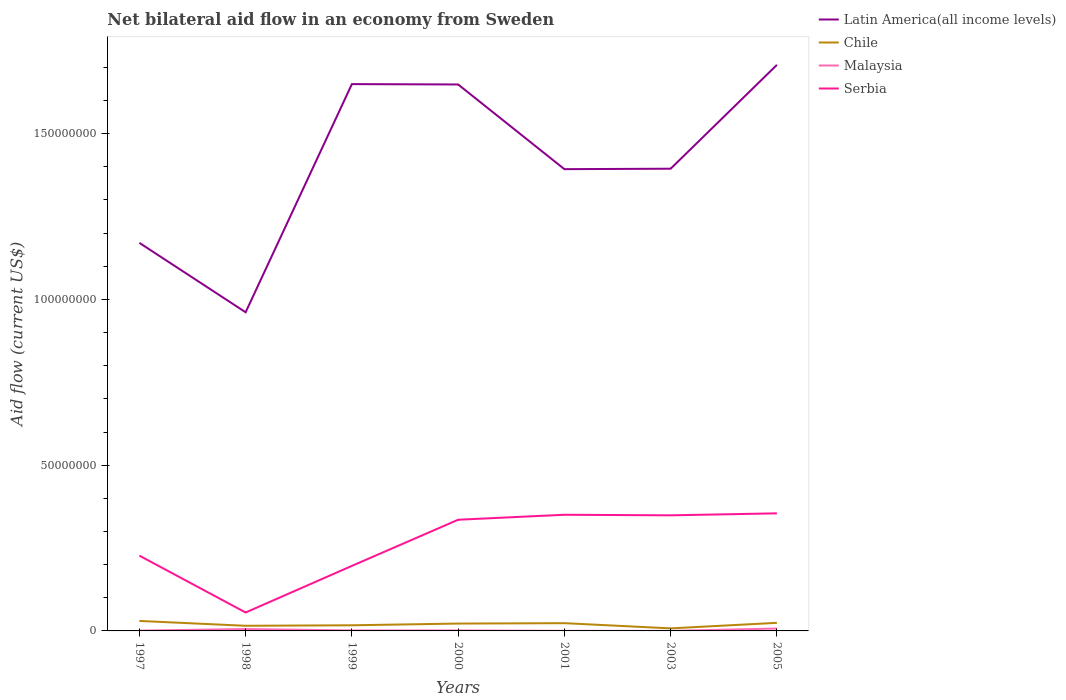Does the line corresponding to Latin America(all income levels) intersect with the line corresponding to Malaysia?
Offer a terse response. No. Across all years, what is the maximum net bilateral aid flow in Latin America(all income levels)?
Your answer should be very brief. 9.61e+07. In which year was the net bilateral aid flow in Chile maximum?
Make the answer very short. 2003. What is the total net bilateral aid flow in Chile in the graph?
Your answer should be very brief. -6.40e+05. What is the difference between the highest and the second highest net bilateral aid flow in Malaysia?
Provide a succinct answer. 7.10e+05. What is the difference between the highest and the lowest net bilateral aid flow in Malaysia?
Keep it short and to the point. 2. How many lines are there?
Make the answer very short. 4. Does the graph contain grids?
Provide a short and direct response. No. How many legend labels are there?
Provide a succinct answer. 4. What is the title of the graph?
Keep it short and to the point. Net bilateral aid flow in an economy from Sweden. Does "Moldova" appear as one of the legend labels in the graph?
Give a very brief answer. No. What is the label or title of the X-axis?
Your response must be concise. Years. What is the Aid flow (current US$) in Latin America(all income levels) in 1997?
Give a very brief answer. 1.17e+08. What is the Aid flow (current US$) in Chile in 1997?
Your answer should be compact. 3.01e+06. What is the Aid flow (current US$) in Malaysia in 1997?
Offer a very short reply. 1.00e+05. What is the Aid flow (current US$) of Serbia in 1997?
Give a very brief answer. 2.27e+07. What is the Aid flow (current US$) of Latin America(all income levels) in 1998?
Give a very brief answer. 9.61e+07. What is the Aid flow (current US$) of Chile in 1998?
Give a very brief answer. 1.55e+06. What is the Aid flow (current US$) of Malaysia in 1998?
Keep it short and to the point. 5.70e+05. What is the Aid flow (current US$) in Serbia in 1998?
Make the answer very short. 5.56e+06. What is the Aid flow (current US$) in Latin America(all income levels) in 1999?
Offer a very short reply. 1.65e+08. What is the Aid flow (current US$) of Chile in 1999?
Give a very brief answer. 1.70e+06. What is the Aid flow (current US$) in Serbia in 1999?
Make the answer very short. 1.96e+07. What is the Aid flow (current US$) in Latin America(all income levels) in 2000?
Offer a very short reply. 1.65e+08. What is the Aid flow (current US$) of Chile in 2000?
Keep it short and to the point. 2.22e+06. What is the Aid flow (current US$) of Malaysia in 2000?
Offer a terse response. 1.40e+05. What is the Aid flow (current US$) of Serbia in 2000?
Give a very brief answer. 3.35e+07. What is the Aid flow (current US$) in Latin America(all income levels) in 2001?
Your answer should be very brief. 1.39e+08. What is the Aid flow (current US$) of Chile in 2001?
Make the answer very short. 2.34e+06. What is the Aid flow (current US$) of Malaysia in 2001?
Provide a succinct answer. 3.00e+04. What is the Aid flow (current US$) in Serbia in 2001?
Offer a terse response. 3.50e+07. What is the Aid flow (current US$) of Latin America(all income levels) in 2003?
Your answer should be compact. 1.39e+08. What is the Aid flow (current US$) in Chile in 2003?
Give a very brief answer. 7.70e+05. What is the Aid flow (current US$) of Serbia in 2003?
Make the answer very short. 3.49e+07. What is the Aid flow (current US$) in Latin America(all income levels) in 2005?
Your response must be concise. 1.71e+08. What is the Aid flow (current US$) in Chile in 2005?
Your response must be concise. 2.44e+06. What is the Aid flow (current US$) in Malaysia in 2005?
Make the answer very short. 7.20e+05. What is the Aid flow (current US$) in Serbia in 2005?
Provide a short and direct response. 3.55e+07. Across all years, what is the maximum Aid flow (current US$) in Latin America(all income levels)?
Provide a short and direct response. 1.71e+08. Across all years, what is the maximum Aid flow (current US$) in Chile?
Your answer should be compact. 3.01e+06. Across all years, what is the maximum Aid flow (current US$) in Malaysia?
Offer a terse response. 7.20e+05. Across all years, what is the maximum Aid flow (current US$) of Serbia?
Provide a succinct answer. 3.55e+07. Across all years, what is the minimum Aid flow (current US$) of Latin America(all income levels)?
Offer a very short reply. 9.61e+07. Across all years, what is the minimum Aid flow (current US$) of Chile?
Give a very brief answer. 7.70e+05. Across all years, what is the minimum Aid flow (current US$) of Serbia?
Keep it short and to the point. 5.56e+06. What is the total Aid flow (current US$) in Latin America(all income levels) in the graph?
Provide a succinct answer. 9.93e+08. What is the total Aid flow (current US$) of Chile in the graph?
Give a very brief answer. 1.40e+07. What is the total Aid flow (current US$) of Malaysia in the graph?
Provide a short and direct response. 1.71e+06. What is the total Aid flow (current US$) in Serbia in the graph?
Your answer should be compact. 1.87e+08. What is the difference between the Aid flow (current US$) of Latin America(all income levels) in 1997 and that in 1998?
Your answer should be very brief. 2.09e+07. What is the difference between the Aid flow (current US$) of Chile in 1997 and that in 1998?
Offer a very short reply. 1.46e+06. What is the difference between the Aid flow (current US$) in Malaysia in 1997 and that in 1998?
Ensure brevity in your answer.  -4.70e+05. What is the difference between the Aid flow (current US$) of Serbia in 1997 and that in 1998?
Give a very brief answer. 1.72e+07. What is the difference between the Aid flow (current US$) in Latin America(all income levels) in 1997 and that in 1999?
Offer a terse response. -4.79e+07. What is the difference between the Aid flow (current US$) in Chile in 1997 and that in 1999?
Ensure brevity in your answer.  1.31e+06. What is the difference between the Aid flow (current US$) in Serbia in 1997 and that in 1999?
Offer a very short reply. 3.09e+06. What is the difference between the Aid flow (current US$) in Latin America(all income levels) in 1997 and that in 2000?
Provide a short and direct response. -4.78e+07. What is the difference between the Aid flow (current US$) in Chile in 1997 and that in 2000?
Make the answer very short. 7.90e+05. What is the difference between the Aid flow (current US$) in Malaysia in 1997 and that in 2000?
Provide a short and direct response. -4.00e+04. What is the difference between the Aid flow (current US$) of Serbia in 1997 and that in 2000?
Ensure brevity in your answer.  -1.08e+07. What is the difference between the Aid flow (current US$) of Latin America(all income levels) in 1997 and that in 2001?
Ensure brevity in your answer.  -2.22e+07. What is the difference between the Aid flow (current US$) in Chile in 1997 and that in 2001?
Provide a succinct answer. 6.70e+05. What is the difference between the Aid flow (current US$) in Malaysia in 1997 and that in 2001?
Make the answer very short. 7.00e+04. What is the difference between the Aid flow (current US$) in Serbia in 1997 and that in 2001?
Keep it short and to the point. -1.23e+07. What is the difference between the Aid flow (current US$) in Latin America(all income levels) in 1997 and that in 2003?
Provide a short and direct response. -2.24e+07. What is the difference between the Aid flow (current US$) of Chile in 1997 and that in 2003?
Ensure brevity in your answer.  2.24e+06. What is the difference between the Aid flow (current US$) in Malaysia in 1997 and that in 2003?
Your answer should be compact. 9.00e+04. What is the difference between the Aid flow (current US$) in Serbia in 1997 and that in 2003?
Keep it short and to the point. -1.22e+07. What is the difference between the Aid flow (current US$) of Latin America(all income levels) in 1997 and that in 2005?
Provide a succinct answer. -5.37e+07. What is the difference between the Aid flow (current US$) in Chile in 1997 and that in 2005?
Offer a very short reply. 5.70e+05. What is the difference between the Aid flow (current US$) in Malaysia in 1997 and that in 2005?
Ensure brevity in your answer.  -6.20e+05. What is the difference between the Aid flow (current US$) of Serbia in 1997 and that in 2005?
Give a very brief answer. -1.28e+07. What is the difference between the Aid flow (current US$) of Latin America(all income levels) in 1998 and that in 1999?
Provide a short and direct response. -6.88e+07. What is the difference between the Aid flow (current US$) of Malaysia in 1998 and that in 1999?
Provide a succinct answer. 4.30e+05. What is the difference between the Aid flow (current US$) in Serbia in 1998 and that in 1999?
Keep it short and to the point. -1.41e+07. What is the difference between the Aid flow (current US$) of Latin America(all income levels) in 1998 and that in 2000?
Give a very brief answer. -6.87e+07. What is the difference between the Aid flow (current US$) of Chile in 1998 and that in 2000?
Keep it short and to the point. -6.70e+05. What is the difference between the Aid flow (current US$) in Serbia in 1998 and that in 2000?
Give a very brief answer. -2.80e+07. What is the difference between the Aid flow (current US$) of Latin America(all income levels) in 1998 and that in 2001?
Offer a terse response. -4.32e+07. What is the difference between the Aid flow (current US$) in Chile in 1998 and that in 2001?
Your response must be concise. -7.90e+05. What is the difference between the Aid flow (current US$) in Malaysia in 1998 and that in 2001?
Keep it short and to the point. 5.40e+05. What is the difference between the Aid flow (current US$) of Serbia in 1998 and that in 2001?
Give a very brief answer. -2.95e+07. What is the difference between the Aid flow (current US$) in Latin America(all income levels) in 1998 and that in 2003?
Offer a very short reply. -4.33e+07. What is the difference between the Aid flow (current US$) in Chile in 1998 and that in 2003?
Your answer should be compact. 7.80e+05. What is the difference between the Aid flow (current US$) in Malaysia in 1998 and that in 2003?
Offer a terse response. 5.60e+05. What is the difference between the Aid flow (current US$) in Serbia in 1998 and that in 2003?
Give a very brief answer. -2.93e+07. What is the difference between the Aid flow (current US$) of Latin America(all income levels) in 1998 and that in 2005?
Offer a terse response. -7.46e+07. What is the difference between the Aid flow (current US$) of Chile in 1998 and that in 2005?
Offer a terse response. -8.90e+05. What is the difference between the Aid flow (current US$) in Malaysia in 1998 and that in 2005?
Give a very brief answer. -1.50e+05. What is the difference between the Aid flow (current US$) in Serbia in 1998 and that in 2005?
Provide a succinct answer. -2.99e+07. What is the difference between the Aid flow (current US$) of Chile in 1999 and that in 2000?
Your answer should be very brief. -5.20e+05. What is the difference between the Aid flow (current US$) in Serbia in 1999 and that in 2000?
Provide a short and direct response. -1.39e+07. What is the difference between the Aid flow (current US$) of Latin America(all income levels) in 1999 and that in 2001?
Offer a very short reply. 2.57e+07. What is the difference between the Aid flow (current US$) in Chile in 1999 and that in 2001?
Make the answer very short. -6.40e+05. What is the difference between the Aid flow (current US$) of Serbia in 1999 and that in 2001?
Provide a succinct answer. -1.54e+07. What is the difference between the Aid flow (current US$) in Latin America(all income levels) in 1999 and that in 2003?
Keep it short and to the point. 2.55e+07. What is the difference between the Aid flow (current US$) of Chile in 1999 and that in 2003?
Provide a succinct answer. 9.30e+05. What is the difference between the Aid flow (current US$) in Serbia in 1999 and that in 2003?
Your answer should be very brief. -1.52e+07. What is the difference between the Aid flow (current US$) of Latin America(all income levels) in 1999 and that in 2005?
Offer a terse response. -5.80e+06. What is the difference between the Aid flow (current US$) of Chile in 1999 and that in 2005?
Your answer should be very brief. -7.40e+05. What is the difference between the Aid flow (current US$) of Malaysia in 1999 and that in 2005?
Provide a succinct answer. -5.80e+05. What is the difference between the Aid flow (current US$) in Serbia in 1999 and that in 2005?
Provide a succinct answer. -1.58e+07. What is the difference between the Aid flow (current US$) of Latin America(all income levels) in 2000 and that in 2001?
Your answer should be very brief. 2.56e+07. What is the difference between the Aid flow (current US$) in Chile in 2000 and that in 2001?
Your response must be concise. -1.20e+05. What is the difference between the Aid flow (current US$) of Malaysia in 2000 and that in 2001?
Ensure brevity in your answer.  1.10e+05. What is the difference between the Aid flow (current US$) of Serbia in 2000 and that in 2001?
Ensure brevity in your answer.  -1.50e+06. What is the difference between the Aid flow (current US$) of Latin America(all income levels) in 2000 and that in 2003?
Provide a short and direct response. 2.54e+07. What is the difference between the Aid flow (current US$) of Chile in 2000 and that in 2003?
Ensure brevity in your answer.  1.45e+06. What is the difference between the Aid flow (current US$) of Malaysia in 2000 and that in 2003?
Your answer should be compact. 1.30e+05. What is the difference between the Aid flow (current US$) of Serbia in 2000 and that in 2003?
Your answer should be very brief. -1.33e+06. What is the difference between the Aid flow (current US$) in Latin America(all income levels) in 2000 and that in 2005?
Ensure brevity in your answer.  -5.91e+06. What is the difference between the Aid flow (current US$) in Chile in 2000 and that in 2005?
Your answer should be compact. -2.20e+05. What is the difference between the Aid flow (current US$) in Malaysia in 2000 and that in 2005?
Give a very brief answer. -5.80e+05. What is the difference between the Aid flow (current US$) of Serbia in 2000 and that in 2005?
Offer a very short reply. -1.93e+06. What is the difference between the Aid flow (current US$) of Chile in 2001 and that in 2003?
Offer a terse response. 1.57e+06. What is the difference between the Aid flow (current US$) in Latin America(all income levels) in 2001 and that in 2005?
Your answer should be compact. -3.15e+07. What is the difference between the Aid flow (current US$) in Chile in 2001 and that in 2005?
Make the answer very short. -1.00e+05. What is the difference between the Aid flow (current US$) of Malaysia in 2001 and that in 2005?
Ensure brevity in your answer.  -6.90e+05. What is the difference between the Aid flow (current US$) of Serbia in 2001 and that in 2005?
Your answer should be very brief. -4.30e+05. What is the difference between the Aid flow (current US$) in Latin America(all income levels) in 2003 and that in 2005?
Make the answer very short. -3.13e+07. What is the difference between the Aid flow (current US$) of Chile in 2003 and that in 2005?
Make the answer very short. -1.67e+06. What is the difference between the Aid flow (current US$) in Malaysia in 2003 and that in 2005?
Make the answer very short. -7.10e+05. What is the difference between the Aid flow (current US$) in Serbia in 2003 and that in 2005?
Provide a short and direct response. -6.00e+05. What is the difference between the Aid flow (current US$) in Latin America(all income levels) in 1997 and the Aid flow (current US$) in Chile in 1998?
Provide a short and direct response. 1.16e+08. What is the difference between the Aid flow (current US$) in Latin America(all income levels) in 1997 and the Aid flow (current US$) in Malaysia in 1998?
Offer a terse response. 1.16e+08. What is the difference between the Aid flow (current US$) of Latin America(all income levels) in 1997 and the Aid flow (current US$) of Serbia in 1998?
Offer a terse response. 1.12e+08. What is the difference between the Aid flow (current US$) in Chile in 1997 and the Aid flow (current US$) in Malaysia in 1998?
Ensure brevity in your answer.  2.44e+06. What is the difference between the Aid flow (current US$) of Chile in 1997 and the Aid flow (current US$) of Serbia in 1998?
Your response must be concise. -2.55e+06. What is the difference between the Aid flow (current US$) in Malaysia in 1997 and the Aid flow (current US$) in Serbia in 1998?
Your response must be concise. -5.46e+06. What is the difference between the Aid flow (current US$) of Latin America(all income levels) in 1997 and the Aid flow (current US$) of Chile in 1999?
Your answer should be compact. 1.15e+08. What is the difference between the Aid flow (current US$) in Latin America(all income levels) in 1997 and the Aid flow (current US$) in Malaysia in 1999?
Offer a terse response. 1.17e+08. What is the difference between the Aid flow (current US$) in Latin America(all income levels) in 1997 and the Aid flow (current US$) in Serbia in 1999?
Keep it short and to the point. 9.74e+07. What is the difference between the Aid flow (current US$) of Chile in 1997 and the Aid flow (current US$) of Malaysia in 1999?
Keep it short and to the point. 2.87e+06. What is the difference between the Aid flow (current US$) in Chile in 1997 and the Aid flow (current US$) in Serbia in 1999?
Keep it short and to the point. -1.66e+07. What is the difference between the Aid flow (current US$) in Malaysia in 1997 and the Aid flow (current US$) in Serbia in 1999?
Give a very brief answer. -1.95e+07. What is the difference between the Aid flow (current US$) in Latin America(all income levels) in 1997 and the Aid flow (current US$) in Chile in 2000?
Provide a short and direct response. 1.15e+08. What is the difference between the Aid flow (current US$) of Latin America(all income levels) in 1997 and the Aid flow (current US$) of Malaysia in 2000?
Your answer should be compact. 1.17e+08. What is the difference between the Aid flow (current US$) of Latin America(all income levels) in 1997 and the Aid flow (current US$) of Serbia in 2000?
Offer a very short reply. 8.35e+07. What is the difference between the Aid flow (current US$) in Chile in 1997 and the Aid flow (current US$) in Malaysia in 2000?
Provide a short and direct response. 2.87e+06. What is the difference between the Aid flow (current US$) in Chile in 1997 and the Aid flow (current US$) in Serbia in 2000?
Your answer should be very brief. -3.05e+07. What is the difference between the Aid flow (current US$) of Malaysia in 1997 and the Aid flow (current US$) of Serbia in 2000?
Provide a succinct answer. -3.34e+07. What is the difference between the Aid flow (current US$) of Latin America(all income levels) in 1997 and the Aid flow (current US$) of Chile in 2001?
Offer a very short reply. 1.15e+08. What is the difference between the Aid flow (current US$) in Latin America(all income levels) in 1997 and the Aid flow (current US$) in Malaysia in 2001?
Offer a terse response. 1.17e+08. What is the difference between the Aid flow (current US$) of Latin America(all income levels) in 1997 and the Aid flow (current US$) of Serbia in 2001?
Your answer should be compact. 8.20e+07. What is the difference between the Aid flow (current US$) in Chile in 1997 and the Aid flow (current US$) in Malaysia in 2001?
Your answer should be compact. 2.98e+06. What is the difference between the Aid flow (current US$) in Chile in 1997 and the Aid flow (current US$) in Serbia in 2001?
Make the answer very short. -3.20e+07. What is the difference between the Aid flow (current US$) of Malaysia in 1997 and the Aid flow (current US$) of Serbia in 2001?
Offer a terse response. -3.49e+07. What is the difference between the Aid flow (current US$) of Latin America(all income levels) in 1997 and the Aid flow (current US$) of Chile in 2003?
Provide a short and direct response. 1.16e+08. What is the difference between the Aid flow (current US$) of Latin America(all income levels) in 1997 and the Aid flow (current US$) of Malaysia in 2003?
Give a very brief answer. 1.17e+08. What is the difference between the Aid flow (current US$) of Latin America(all income levels) in 1997 and the Aid flow (current US$) of Serbia in 2003?
Your answer should be very brief. 8.22e+07. What is the difference between the Aid flow (current US$) of Chile in 1997 and the Aid flow (current US$) of Serbia in 2003?
Give a very brief answer. -3.19e+07. What is the difference between the Aid flow (current US$) of Malaysia in 1997 and the Aid flow (current US$) of Serbia in 2003?
Offer a terse response. -3.48e+07. What is the difference between the Aid flow (current US$) in Latin America(all income levels) in 1997 and the Aid flow (current US$) in Chile in 2005?
Make the answer very short. 1.15e+08. What is the difference between the Aid flow (current US$) of Latin America(all income levels) in 1997 and the Aid flow (current US$) of Malaysia in 2005?
Your answer should be compact. 1.16e+08. What is the difference between the Aid flow (current US$) of Latin America(all income levels) in 1997 and the Aid flow (current US$) of Serbia in 2005?
Keep it short and to the point. 8.16e+07. What is the difference between the Aid flow (current US$) of Chile in 1997 and the Aid flow (current US$) of Malaysia in 2005?
Ensure brevity in your answer.  2.29e+06. What is the difference between the Aid flow (current US$) in Chile in 1997 and the Aid flow (current US$) in Serbia in 2005?
Your answer should be compact. -3.25e+07. What is the difference between the Aid flow (current US$) of Malaysia in 1997 and the Aid flow (current US$) of Serbia in 2005?
Give a very brief answer. -3.54e+07. What is the difference between the Aid flow (current US$) in Latin America(all income levels) in 1998 and the Aid flow (current US$) in Chile in 1999?
Ensure brevity in your answer.  9.44e+07. What is the difference between the Aid flow (current US$) in Latin America(all income levels) in 1998 and the Aid flow (current US$) in Malaysia in 1999?
Give a very brief answer. 9.60e+07. What is the difference between the Aid flow (current US$) of Latin America(all income levels) in 1998 and the Aid flow (current US$) of Serbia in 1999?
Ensure brevity in your answer.  7.65e+07. What is the difference between the Aid flow (current US$) in Chile in 1998 and the Aid flow (current US$) in Malaysia in 1999?
Keep it short and to the point. 1.41e+06. What is the difference between the Aid flow (current US$) of Chile in 1998 and the Aid flow (current US$) of Serbia in 1999?
Your answer should be very brief. -1.81e+07. What is the difference between the Aid flow (current US$) of Malaysia in 1998 and the Aid flow (current US$) of Serbia in 1999?
Make the answer very short. -1.90e+07. What is the difference between the Aid flow (current US$) in Latin America(all income levels) in 1998 and the Aid flow (current US$) in Chile in 2000?
Keep it short and to the point. 9.39e+07. What is the difference between the Aid flow (current US$) in Latin America(all income levels) in 1998 and the Aid flow (current US$) in Malaysia in 2000?
Ensure brevity in your answer.  9.60e+07. What is the difference between the Aid flow (current US$) of Latin America(all income levels) in 1998 and the Aid flow (current US$) of Serbia in 2000?
Keep it short and to the point. 6.26e+07. What is the difference between the Aid flow (current US$) in Chile in 1998 and the Aid flow (current US$) in Malaysia in 2000?
Provide a short and direct response. 1.41e+06. What is the difference between the Aid flow (current US$) of Chile in 1998 and the Aid flow (current US$) of Serbia in 2000?
Give a very brief answer. -3.20e+07. What is the difference between the Aid flow (current US$) in Malaysia in 1998 and the Aid flow (current US$) in Serbia in 2000?
Provide a succinct answer. -3.30e+07. What is the difference between the Aid flow (current US$) in Latin America(all income levels) in 1998 and the Aid flow (current US$) in Chile in 2001?
Your response must be concise. 9.38e+07. What is the difference between the Aid flow (current US$) in Latin America(all income levels) in 1998 and the Aid flow (current US$) in Malaysia in 2001?
Provide a short and direct response. 9.61e+07. What is the difference between the Aid flow (current US$) in Latin America(all income levels) in 1998 and the Aid flow (current US$) in Serbia in 2001?
Keep it short and to the point. 6.11e+07. What is the difference between the Aid flow (current US$) of Chile in 1998 and the Aid flow (current US$) of Malaysia in 2001?
Offer a very short reply. 1.52e+06. What is the difference between the Aid flow (current US$) of Chile in 1998 and the Aid flow (current US$) of Serbia in 2001?
Offer a terse response. -3.35e+07. What is the difference between the Aid flow (current US$) in Malaysia in 1998 and the Aid flow (current US$) in Serbia in 2001?
Your response must be concise. -3.45e+07. What is the difference between the Aid flow (current US$) of Latin America(all income levels) in 1998 and the Aid flow (current US$) of Chile in 2003?
Make the answer very short. 9.54e+07. What is the difference between the Aid flow (current US$) in Latin America(all income levels) in 1998 and the Aid flow (current US$) in Malaysia in 2003?
Offer a very short reply. 9.61e+07. What is the difference between the Aid flow (current US$) in Latin America(all income levels) in 1998 and the Aid flow (current US$) in Serbia in 2003?
Provide a short and direct response. 6.13e+07. What is the difference between the Aid flow (current US$) of Chile in 1998 and the Aid flow (current US$) of Malaysia in 2003?
Your response must be concise. 1.54e+06. What is the difference between the Aid flow (current US$) of Chile in 1998 and the Aid flow (current US$) of Serbia in 2003?
Your answer should be compact. -3.33e+07. What is the difference between the Aid flow (current US$) of Malaysia in 1998 and the Aid flow (current US$) of Serbia in 2003?
Your answer should be very brief. -3.43e+07. What is the difference between the Aid flow (current US$) of Latin America(all income levels) in 1998 and the Aid flow (current US$) of Chile in 2005?
Offer a terse response. 9.37e+07. What is the difference between the Aid flow (current US$) of Latin America(all income levels) in 1998 and the Aid flow (current US$) of Malaysia in 2005?
Your answer should be very brief. 9.54e+07. What is the difference between the Aid flow (current US$) in Latin America(all income levels) in 1998 and the Aid flow (current US$) in Serbia in 2005?
Your answer should be compact. 6.07e+07. What is the difference between the Aid flow (current US$) in Chile in 1998 and the Aid flow (current US$) in Malaysia in 2005?
Provide a short and direct response. 8.30e+05. What is the difference between the Aid flow (current US$) in Chile in 1998 and the Aid flow (current US$) in Serbia in 2005?
Provide a short and direct response. -3.39e+07. What is the difference between the Aid flow (current US$) in Malaysia in 1998 and the Aid flow (current US$) in Serbia in 2005?
Your answer should be compact. -3.49e+07. What is the difference between the Aid flow (current US$) of Latin America(all income levels) in 1999 and the Aid flow (current US$) of Chile in 2000?
Keep it short and to the point. 1.63e+08. What is the difference between the Aid flow (current US$) of Latin America(all income levels) in 1999 and the Aid flow (current US$) of Malaysia in 2000?
Your answer should be very brief. 1.65e+08. What is the difference between the Aid flow (current US$) of Latin America(all income levels) in 1999 and the Aid flow (current US$) of Serbia in 2000?
Your answer should be very brief. 1.31e+08. What is the difference between the Aid flow (current US$) of Chile in 1999 and the Aid flow (current US$) of Malaysia in 2000?
Offer a very short reply. 1.56e+06. What is the difference between the Aid flow (current US$) in Chile in 1999 and the Aid flow (current US$) in Serbia in 2000?
Your answer should be compact. -3.18e+07. What is the difference between the Aid flow (current US$) in Malaysia in 1999 and the Aid flow (current US$) in Serbia in 2000?
Your response must be concise. -3.34e+07. What is the difference between the Aid flow (current US$) of Latin America(all income levels) in 1999 and the Aid flow (current US$) of Chile in 2001?
Offer a terse response. 1.63e+08. What is the difference between the Aid flow (current US$) in Latin America(all income levels) in 1999 and the Aid flow (current US$) in Malaysia in 2001?
Your answer should be compact. 1.65e+08. What is the difference between the Aid flow (current US$) in Latin America(all income levels) in 1999 and the Aid flow (current US$) in Serbia in 2001?
Keep it short and to the point. 1.30e+08. What is the difference between the Aid flow (current US$) in Chile in 1999 and the Aid flow (current US$) in Malaysia in 2001?
Make the answer very short. 1.67e+06. What is the difference between the Aid flow (current US$) of Chile in 1999 and the Aid flow (current US$) of Serbia in 2001?
Your answer should be very brief. -3.33e+07. What is the difference between the Aid flow (current US$) of Malaysia in 1999 and the Aid flow (current US$) of Serbia in 2001?
Provide a short and direct response. -3.49e+07. What is the difference between the Aid flow (current US$) of Latin America(all income levels) in 1999 and the Aid flow (current US$) of Chile in 2003?
Your answer should be compact. 1.64e+08. What is the difference between the Aid flow (current US$) of Latin America(all income levels) in 1999 and the Aid flow (current US$) of Malaysia in 2003?
Your response must be concise. 1.65e+08. What is the difference between the Aid flow (current US$) of Latin America(all income levels) in 1999 and the Aid flow (current US$) of Serbia in 2003?
Offer a very short reply. 1.30e+08. What is the difference between the Aid flow (current US$) of Chile in 1999 and the Aid flow (current US$) of Malaysia in 2003?
Keep it short and to the point. 1.69e+06. What is the difference between the Aid flow (current US$) of Chile in 1999 and the Aid flow (current US$) of Serbia in 2003?
Keep it short and to the point. -3.32e+07. What is the difference between the Aid flow (current US$) of Malaysia in 1999 and the Aid flow (current US$) of Serbia in 2003?
Your answer should be compact. -3.47e+07. What is the difference between the Aid flow (current US$) of Latin America(all income levels) in 1999 and the Aid flow (current US$) of Chile in 2005?
Give a very brief answer. 1.63e+08. What is the difference between the Aid flow (current US$) in Latin America(all income levels) in 1999 and the Aid flow (current US$) in Malaysia in 2005?
Your answer should be very brief. 1.64e+08. What is the difference between the Aid flow (current US$) in Latin America(all income levels) in 1999 and the Aid flow (current US$) in Serbia in 2005?
Provide a short and direct response. 1.29e+08. What is the difference between the Aid flow (current US$) of Chile in 1999 and the Aid flow (current US$) of Malaysia in 2005?
Your answer should be very brief. 9.80e+05. What is the difference between the Aid flow (current US$) in Chile in 1999 and the Aid flow (current US$) in Serbia in 2005?
Your answer should be very brief. -3.38e+07. What is the difference between the Aid flow (current US$) in Malaysia in 1999 and the Aid flow (current US$) in Serbia in 2005?
Offer a terse response. -3.53e+07. What is the difference between the Aid flow (current US$) of Latin America(all income levels) in 2000 and the Aid flow (current US$) of Chile in 2001?
Give a very brief answer. 1.63e+08. What is the difference between the Aid flow (current US$) in Latin America(all income levels) in 2000 and the Aid flow (current US$) in Malaysia in 2001?
Your answer should be very brief. 1.65e+08. What is the difference between the Aid flow (current US$) of Latin America(all income levels) in 2000 and the Aid flow (current US$) of Serbia in 2001?
Provide a short and direct response. 1.30e+08. What is the difference between the Aid flow (current US$) of Chile in 2000 and the Aid flow (current US$) of Malaysia in 2001?
Offer a very short reply. 2.19e+06. What is the difference between the Aid flow (current US$) in Chile in 2000 and the Aid flow (current US$) in Serbia in 2001?
Your answer should be compact. -3.28e+07. What is the difference between the Aid flow (current US$) of Malaysia in 2000 and the Aid flow (current US$) of Serbia in 2001?
Provide a short and direct response. -3.49e+07. What is the difference between the Aid flow (current US$) of Latin America(all income levels) in 2000 and the Aid flow (current US$) of Chile in 2003?
Your answer should be compact. 1.64e+08. What is the difference between the Aid flow (current US$) of Latin America(all income levels) in 2000 and the Aid flow (current US$) of Malaysia in 2003?
Give a very brief answer. 1.65e+08. What is the difference between the Aid flow (current US$) of Latin America(all income levels) in 2000 and the Aid flow (current US$) of Serbia in 2003?
Your response must be concise. 1.30e+08. What is the difference between the Aid flow (current US$) of Chile in 2000 and the Aid flow (current US$) of Malaysia in 2003?
Keep it short and to the point. 2.21e+06. What is the difference between the Aid flow (current US$) in Chile in 2000 and the Aid flow (current US$) in Serbia in 2003?
Keep it short and to the point. -3.26e+07. What is the difference between the Aid flow (current US$) of Malaysia in 2000 and the Aid flow (current US$) of Serbia in 2003?
Your answer should be compact. -3.47e+07. What is the difference between the Aid flow (current US$) of Latin America(all income levels) in 2000 and the Aid flow (current US$) of Chile in 2005?
Offer a very short reply. 1.62e+08. What is the difference between the Aid flow (current US$) of Latin America(all income levels) in 2000 and the Aid flow (current US$) of Malaysia in 2005?
Make the answer very short. 1.64e+08. What is the difference between the Aid flow (current US$) in Latin America(all income levels) in 2000 and the Aid flow (current US$) in Serbia in 2005?
Your answer should be compact. 1.29e+08. What is the difference between the Aid flow (current US$) in Chile in 2000 and the Aid flow (current US$) in Malaysia in 2005?
Provide a succinct answer. 1.50e+06. What is the difference between the Aid flow (current US$) in Chile in 2000 and the Aid flow (current US$) in Serbia in 2005?
Make the answer very short. -3.32e+07. What is the difference between the Aid flow (current US$) of Malaysia in 2000 and the Aid flow (current US$) of Serbia in 2005?
Make the answer very short. -3.53e+07. What is the difference between the Aid flow (current US$) of Latin America(all income levels) in 2001 and the Aid flow (current US$) of Chile in 2003?
Make the answer very short. 1.39e+08. What is the difference between the Aid flow (current US$) in Latin America(all income levels) in 2001 and the Aid flow (current US$) in Malaysia in 2003?
Provide a succinct answer. 1.39e+08. What is the difference between the Aid flow (current US$) in Latin America(all income levels) in 2001 and the Aid flow (current US$) in Serbia in 2003?
Give a very brief answer. 1.04e+08. What is the difference between the Aid flow (current US$) of Chile in 2001 and the Aid flow (current US$) of Malaysia in 2003?
Your response must be concise. 2.33e+06. What is the difference between the Aid flow (current US$) in Chile in 2001 and the Aid flow (current US$) in Serbia in 2003?
Your answer should be compact. -3.25e+07. What is the difference between the Aid flow (current US$) of Malaysia in 2001 and the Aid flow (current US$) of Serbia in 2003?
Provide a succinct answer. -3.48e+07. What is the difference between the Aid flow (current US$) of Latin America(all income levels) in 2001 and the Aid flow (current US$) of Chile in 2005?
Your answer should be compact. 1.37e+08. What is the difference between the Aid flow (current US$) of Latin America(all income levels) in 2001 and the Aid flow (current US$) of Malaysia in 2005?
Offer a very short reply. 1.39e+08. What is the difference between the Aid flow (current US$) of Latin America(all income levels) in 2001 and the Aid flow (current US$) of Serbia in 2005?
Give a very brief answer. 1.04e+08. What is the difference between the Aid flow (current US$) of Chile in 2001 and the Aid flow (current US$) of Malaysia in 2005?
Your response must be concise. 1.62e+06. What is the difference between the Aid flow (current US$) in Chile in 2001 and the Aid flow (current US$) in Serbia in 2005?
Provide a short and direct response. -3.31e+07. What is the difference between the Aid flow (current US$) of Malaysia in 2001 and the Aid flow (current US$) of Serbia in 2005?
Ensure brevity in your answer.  -3.54e+07. What is the difference between the Aid flow (current US$) in Latin America(all income levels) in 2003 and the Aid flow (current US$) in Chile in 2005?
Offer a terse response. 1.37e+08. What is the difference between the Aid flow (current US$) of Latin America(all income levels) in 2003 and the Aid flow (current US$) of Malaysia in 2005?
Your answer should be compact. 1.39e+08. What is the difference between the Aid flow (current US$) in Latin America(all income levels) in 2003 and the Aid flow (current US$) in Serbia in 2005?
Make the answer very short. 1.04e+08. What is the difference between the Aid flow (current US$) of Chile in 2003 and the Aid flow (current US$) of Serbia in 2005?
Your answer should be compact. -3.47e+07. What is the difference between the Aid flow (current US$) in Malaysia in 2003 and the Aid flow (current US$) in Serbia in 2005?
Your response must be concise. -3.55e+07. What is the average Aid flow (current US$) of Latin America(all income levels) per year?
Give a very brief answer. 1.42e+08. What is the average Aid flow (current US$) of Chile per year?
Ensure brevity in your answer.  2.00e+06. What is the average Aid flow (current US$) in Malaysia per year?
Your response must be concise. 2.44e+05. What is the average Aid flow (current US$) in Serbia per year?
Ensure brevity in your answer.  2.67e+07. In the year 1997, what is the difference between the Aid flow (current US$) in Latin America(all income levels) and Aid flow (current US$) in Chile?
Your answer should be very brief. 1.14e+08. In the year 1997, what is the difference between the Aid flow (current US$) of Latin America(all income levels) and Aid flow (current US$) of Malaysia?
Offer a very short reply. 1.17e+08. In the year 1997, what is the difference between the Aid flow (current US$) of Latin America(all income levels) and Aid flow (current US$) of Serbia?
Ensure brevity in your answer.  9.44e+07. In the year 1997, what is the difference between the Aid flow (current US$) in Chile and Aid flow (current US$) in Malaysia?
Make the answer very short. 2.91e+06. In the year 1997, what is the difference between the Aid flow (current US$) of Chile and Aid flow (current US$) of Serbia?
Offer a very short reply. -1.97e+07. In the year 1997, what is the difference between the Aid flow (current US$) in Malaysia and Aid flow (current US$) in Serbia?
Give a very brief answer. -2.26e+07. In the year 1998, what is the difference between the Aid flow (current US$) of Latin America(all income levels) and Aid flow (current US$) of Chile?
Ensure brevity in your answer.  9.46e+07. In the year 1998, what is the difference between the Aid flow (current US$) of Latin America(all income levels) and Aid flow (current US$) of Malaysia?
Offer a terse response. 9.56e+07. In the year 1998, what is the difference between the Aid flow (current US$) of Latin America(all income levels) and Aid flow (current US$) of Serbia?
Offer a very short reply. 9.06e+07. In the year 1998, what is the difference between the Aid flow (current US$) in Chile and Aid flow (current US$) in Malaysia?
Make the answer very short. 9.80e+05. In the year 1998, what is the difference between the Aid flow (current US$) in Chile and Aid flow (current US$) in Serbia?
Make the answer very short. -4.01e+06. In the year 1998, what is the difference between the Aid flow (current US$) in Malaysia and Aid flow (current US$) in Serbia?
Keep it short and to the point. -4.99e+06. In the year 1999, what is the difference between the Aid flow (current US$) of Latin America(all income levels) and Aid flow (current US$) of Chile?
Provide a succinct answer. 1.63e+08. In the year 1999, what is the difference between the Aid flow (current US$) in Latin America(all income levels) and Aid flow (current US$) in Malaysia?
Offer a very short reply. 1.65e+08. In the year 1999, what is the difference between the Aid flow (current US$) in Latin America(all income levels) and Aid flow (current US$) in Serbia?
Your answer should be very brief. 1.45e+08. In the year 1999, what is the difference between the Aid flow (current US$) in Chile and Aid flow (current US$) in Malaysia?
Your response must be concise. 1.56e+06. In the year 1999, what is the difference between the Aid flow (current US$) in Chile and Aid flow (current US$) in Serbia?
Ensure brevity in your answer.  -1.79e+07. In the year 1999, what is the difference between the Aid flow (current US$) of Malaysia and Aid flow (current US$) of Serbia?
Make the answer very short. -1.95e+07. In the year 2000, what is the difference between the Aid flow (current US$) in Latin America(all income levels) and Aid flow (current US$) in Chile?
Offer a terse response. 1.63e+08. In the year 2000, what is the difference between the Aid flow (current US$) in Latin America(all income levels) and Aid flow (current US$) in Malaysia?
Keep it short and to the point. 1.65e+08. In the year 2000, what is the difference between the Aid flow (current US$) of Latin America(all income levels) and Aid flow (current US$) of Serbia?
Provide a succinct answer. 1.31e+08. In the year 2000, what is the difference between the Aid flow (current US$) in Chile and Aid flow (current US$) in Malaysia?
Your response must be concise. 2.08e+06. In the year 2000, what is the difference between the Aid flow (current US$) in Chile and Aid flow (current US$) in Serbia?
Provide a succinct answer. -3.13e+07. In the year 2000, what is the difference between the Aid flow (current US$) of Malaysia and Aid flow (current US$) of Serbia?
Make the answer very short. -3.34e+07. In the year 2001, what is the difference between the Aid flow (current US$) of Latin America(all income levels) and Aid flow (current US$) of Chile?
Your answer should be compact. 1.37e+08. In the year 2001, what is the difference between the Aid flow (current US$) of Latin America(all income levels) and Aid flow (current US$) of Malaysia?
Ensure brevity in your answer.  1.39e+08. In the year 2001, what is the difference between the Aid flow (current US$) of Latin America(all income levels) and Aid flow (current US$) of Serbia?
Make the answer very short. 1.04e+08. In the year 2001, what is the difference between the Aid flow (current US$) of Chile and Aid flow (current US$) of Malaysia?
Your response must be concise. 2.31e+06. In the year 2001, what is the difference between the Aid flow (current US$) in Chile and Aid flow (current US$) in Serbia?
Make the answer very short. -3.27e+07. In the year 2001, what is the difference between the Aid flow (current US$) of Malaysia and Aid flow (current US$) of Serbia?
Offer a very short reply. -3.50e+07. In the year 2003, what is the difference between the Aid flow (current US$) in Latin America(all income levels) and Aid flow (current US$) in Chile?
Provide a short and direct response. 1.39e+08. In the year 2003, what is the difference between the Aid flow (current US$) of Latin America(all income levels) and Aid flow (current US$) of Malaysia?
Your response must be concise. 1.39e+08. In the year 2003, what is the difference between the Aid flow (current US$) of Latin America(all income levels) and Aid flow (current US$) of Serbia?
Ensure brevity in your answer.  1.05e+08. In the year 2003, what is the difference between the Aid flow (current US$) of Chile and Aid flow (current US$) of Malaysia?
Make the answer very short. 7.60e+05. In the year 2003, what is the difference between the Aid flow (current US$) of Chile and Aid flow (current US$) of Serbia?
Keep it short and to the point. -3.41e+07. In the year 2003, what is the difference between the Aid flow (current US$) of Malaysia and Aid flow (current US$) of Serbia?
Give a very brief answer. -3.49e+07. In the year 2005, what is the difference between the Aid flow (current US$) of Latin America(all income levels) and Aid flow (current US$) of Chile?
Provide a succinct answer. 1.68e+08. In the year 2005, what is the difference between the Aid flow (current US$) in Latin America(all income levels) and Aid flow (current US$) in Malaysia?
Make the answer very short. 1.70e+08. In the year 2005, what is the difference between the Aid flow (current US$) in Latin America(all income levels) and Aid flow (current US$) in Serbia?
Give a very brief answer. 1.35e+08. In the year 2005, what is the difference between the Aid flow (current US$) in Chile and Aid flow (current US$) in Malaysia?
Provide a succinct answer. 1.72e+06. In the year 2005, what is the difference between the Aid flow (current US$) in Chile and Aid flow (current US$) in Serbia?
Ensure brevity in your answer.  -3.30e+07. In the year 2005, what is the difference between the Aid flow (current US$) of Malaysia and Aid flow (current US$) of Serbia?
Ensure brevity in your answer.  -3.48e+07. What is the ratio of the Aid flow (current US$) in Latin America(all income levels) in 1997 to that in 1998?
Your answer should be compact. 1.22. What is the ratio of the Aid flow (current US$) of Chile in 1997 to that in 1998?
Your answer should be compact. 1.94. What is the ratio of the Aid flow (current US$) of Malaysia in 1997 to that in 1998?
Offer a very short reply. 0.18. What is the ratio of the Aid flow (current US$) of Serbia in 1997 to that in 1998?
Ensure brevity in your answer.  4.08. What is the ratio of the Aid flow (current US$) of Latin America(all income levels) in 1997 to that in 1999?
Keep it short and to the point. 0.71. What is the ratio of the Aid flow (current US$) of Chile in 1997 to that in 1999?
Provide a short and direct response. 1.77. What is the ratio of the Aid flow (current US$) of Malaysia in 1997 to that in 1999?
Keep it short and to the point. 0.71. What is the ratio of the Aid flow (current US$) in Serbia in 1997 to that in 1999?
Your response must be concise. 1.16. What is the ratio of the Aid flow (current US$) in Latin America(all income levels) in 1997 to that in 2000?
Ensure brevity in your answer.  0.71. What is the ratio of the Aid flow (current US$) of Chile in 1997 to that in 2000?
Make the answer very short. 1.36. What is the ratio of the Aid flow (current US$) in Malaysia in 1997 to that in 2000?
Offer a very short reply. 0.71. What is the ratio of the Aid flow (current US$) of Serbia in 1997 to that in 2000?
Ensure brevity in your answer.  0.68. What is the ratio of the Aid flow (current US$) in Latin America(all income levels) in 1997 to that in 2001?
Provide a succinct answer. 0.84. What is the ratio of the Aid flow (current US$) in Chile in 1997 to that in 2001?
Your answer should be compact. 1.29. What is the ratio of the Aid flow (current US$) in Malaysia in 1997 to that in 2001?
Give a very brief answer. 3.33. What is the ratio of the Aid flow (current US$) in Serbia in 1997 to that in 2001?
Provide a succinct answer. 0.65. What is the ratio of the Aid flow (current US$) of Latin America(all income levels) in 1997 to that in 2003?
Your answer should be compact. 0.84. What is the ratio of the Aid flow (current US$) of Chile in 1997 to that in 2003?
Ensure brevity in your answer.  3.91. What is the ratio of the Aid flow (current US$) in Malaysia in 1997 to that in 2003?
Your response must be concise. 10. What is the ratio of the Aid flow (current US$) in Serbia in 1997 to that in 2003?
Keep it short and to the point. 0.65. What is the ratio of the Aid flow (current US$) of Latin America(all income levels) in 1997 to that in 2005?
Give a very brief answer. 0.69. What is the ratio of the Aid flow (current US$) of Chile in 1997 to that in 2005?
Give a very brief answer. 1.23. What is the ratio of the Aid flow (current US$) in Malaysia in 1997 to that in 2005?
Offer a terse response. 0.14. What is the ratio of the Aid flow (current US$) in Serbia in 1997 to that in 2005?
Give a very brief answer. 0.64. What is the ratio of the Aid flow (current US$) of Latin America(all income levels) in 1998 to that in 1999?
Your answer should be very brief. 0.58. What is the ratio of the Aid flow (current US$) in Chile in 1998 to that in 1999?
Give a very brief answer. 0.91. What is the ratio of the Aid flow (current US$) of Malaysia in 1998 to that in 1999?
Ensure brevity in your answer.  4.07. What is the ratio of the Aid flow (current US$) in Serbia in 1998 to that in 1999?
Provide a short and direct response. 0.28. What is the ratio of the Aid flow (current US$) of Latin America(all income levels) in 1998 to that in 2000?
Provide a succinct answer. 0.58. What is the ratio of the Aid flow (current US$) of Chile in 1998 to that in 2000?
Give a very brief answer. 0.7. What is the ratio of the Aid flow (current US$) of Malaysia in 1998 to that in 2000?
Your answer should be compact. 4.07. What is the ratio of the Aid flow (current US$) in Serbia in 1998 to that in 2000?
Keep it short and to the point. 0.17. What is the ratio of the Aid flow (current US$) of Latin America(all income levels) in 1998 to that in 2001?
Keep it short and to the point. 0.69. What is the ratio of the Aid flow (current US$) in Chile in 1998 to that in 2001?
Offer a terse response. 0.66. What is the ratio of the Aid flow (current US$) of Serbia in 1998 to that in 2001?
Provide a short and direct response. 0.16. What is the ratio of the Aid flow (current US$) of Latin America(all income levels) in 1998 to that in 2003?
Your response must be concise. 0.69. What is the ratio of the Aid flow (current US$) of Chile in 1998 to that in 2003?
Ensure brevity in your answer.  2.01. What is the ratio of the Aid flow (current US$) in Malaysia in 1998 to that in 2003?
Provide a short and direct response. 57. What is the ratio of the Aid flow (current US$) of Serbia in 1998 to that in 2003?
Keep it short and to the point. 0.16. What is the ratio of the Aid flow (current US$) in Latin America(all income levels) in 1998 to that in 2005?
Your answer should be compact. 0.56. What is the ratio of the Aid flow (current US$) of Chile in 1998 to that in 2005?
Offer a very short reply. 0.64. What is the ratio of the Aid flow (current US$) of Malaysia in 1998 to that in 2005?
Make the answer very short. 0.79. What is the ratio of the Aid flow (current US$) in Serbia in 1998 to that in 2005?
Keep it short and to the point. 0.16. What is the ratio of the Aid flow (current US$) of Latin America(all income levels) in 1999 to that in 2000?
Make the answer very short. 1. What is the ratio of the Aid flow (current US$) of Chile in 1999 to that in 2000?
Offer a very short reply. 0.77. What is the ratio of the Aid flow (current US$) of Malaysia in 1999 to that in 2000?
Offer a terse response. 1. What is the ratio of the Aid flow (current US$) in Serbia in 1999 to that in 2000?
Your answer should be very brief. 0.58. What is the ratio of the Aid flow (current US$) in Latin America(all income levels) in 1999 to that in 2001?
Provide a succinct answer. 1.18. What is the ratio of the Aid flow (current US$) in Chile in 1999 to that in 2001?
Provide a succinct answer. 0.73. What is the ratio of the Aid flow (current US$) of Malaysia in 1999 to that in 2001?
Your answer should be compact. 4.67. What is the ratio of the Aid flow (current US$) of Serbia in 1999 to that in 2001?
Keep it short and to the point. 0.56. What is the ratio of the Aid flow (current US$) of Latin America(all income levels) in 1999 to that in 2003?
Offer a terse response. 1.18. What is the ratio of the Aid flow (current US$) of Chile in 1999 to that in 2003?
Offer a terse response. 2.21. What is the ratio of the Aid flow (current US$) in Malaysia in 1999 to that in 2003?
Offer a terse response. 14. What is the ratio of the Aid flow (current US$) of Serbia in 1999 to that in 2003?
Your answer should be very brief. 0.56. What is the ratio of the Aid flow (current US$) of Chile in 1999 to that in 2005?
Offer a terse response. 0.7. What is the ratio of the Aid flow (current US$) of Malaysia in 1999 to that in 2005?
Your response must be concise. 0.19. What is the ratio of the Aid flow (current US$) in Serbia in 1999 to that in 2005?
Make the answer very short. 0.55. What is the ratio of the Aid flow (current US$) in Latin America(all income levels) in 2000 to that in 2001?
Ensure brevity in your answer.  1.18. What is the ratio of the Aid flow (current US$) of Chile in 2000 to that in 2001?
Your response must be concise. 0.95. What is the ratio of the Aid flow (current US$) of Malaysia in 2000 to that in 2001?
Give a very brief answer. 4.67. What is the ratio of the Aid flow (current US$) of Serbia in 2000 to that in 2001?
Your response must be concise. 0.96. What is the ratio of the Aid flow (current US$) in Latin America(all income levels) in 2000 to that in 2003?
Give a very brief answer. 1.18. What is the ratio of the Aid flow (current US$) in Chile in 2000 to that in 2003?
Your answer should be compact. 2.88. What is the ratio of the Aid flow (current US$) in Serbia in 2000 to that in 2003?
Your answer should be compact. 0.96. What is the ratio of the Aid flow (current US$) in Latin America(all income levels) in 2000 to that in 2005?
Provide a succinct answer. 0.97. What is the ratio of the Aid flow (current US$) in Chile in 2000 to that in 2005?
Provide a succinct answer. 0.91. What is the ratio of the Aid flow (current US$) in Malaysia in 2000 to that in 2005?
Provide a succinct answer. 0.19. What is the ratio of the Aid flow (current US$) of Serbia in 2000 to that in 2005?
Ensure brevity in your answer.  0.95. What is the ratio of the Aid flow (current US$) of Latin America(all income levels) in 2001 to that in 2003?
Your answer should be very brief. 1. What is the ratio of the Aid flow (current US$) in Chile in 2001 to that in 2003?
Your answer should be very brief. 3.04. What is the ratio of the Aid flow (current US$) in Serbia in 2001 to that in 2003?
Provide a succinct answer. 1. What is the ratio of the Aid flow (current US$) in Latin America(all income levels) in 2001 to that in 2005?
Your response must be concise. 0.82. What is the ratio of the Aid flow (current US$) in Chile in 2001 to that in 2005?
Give a very brief answer. 0.96. What is the ratio of the Aid flow (current US$) in Malaysia in 2001 to that in 2005?
Provide a short and direct response. 0.04. What is the ratio of the Aid flow (current US$) in Serbia in 2001 to that in 2005?
Ensure brevity in your answer.  0.99. What is the ratio of the Aid flow (current US$) of Latin America(all income levels) in 2003 to that in 2005?
Provide a short and direct response. 0.82. What is the ratio of the Aid flow (current US$) in Chile in 2003 to that in 2005?
Provide a short and direct response. 0.32. What is the ratio of the Aid flow (current US$) of Malaysia in 2003 to that in 2005?
Ensure brevity in your answer.  0.01. What is the ratio of the Aid flow (current US$) of Serbia in 2003 to that in 2005?
Offer a terse response. 0.98. What is the difference between the highest and the second highest Aid flow (current US$) in Latin America(all income levels)?
Your answer should be compact. 5.80e+06. What is the difference between the highest and the second highest Aid flow (current US$) of Chile?
Ensure brevity in your answer.  5.70e+05. What is the difference between the highest and the second highest Aid flow (current US$) of Malaysia?
Offer a very short reply. 1.50e+05. What is the difference between the highest and the second highest Aid flow (current US$) in Serbia?
Make the answer very short. 4.30e+05. What is the difference between the highest and the lowest Aid flow (current US$) of Latin America(all income levels)?
Provide a short and direct response. 7.46e+07. What is the difference between the highest and the lowest Aid flow (current US$) in Chile?
Make the answer very short. 2.24e+06. What is the difference between the highest and the lowest Aid flow (current US$) in Malaysia?
Provide a succinct answer. 7.10e+05. What is the difference between the highest and the lowest Aid flow (current US$) in Serbia?
Give a very brief answer. 2.99e+07. 